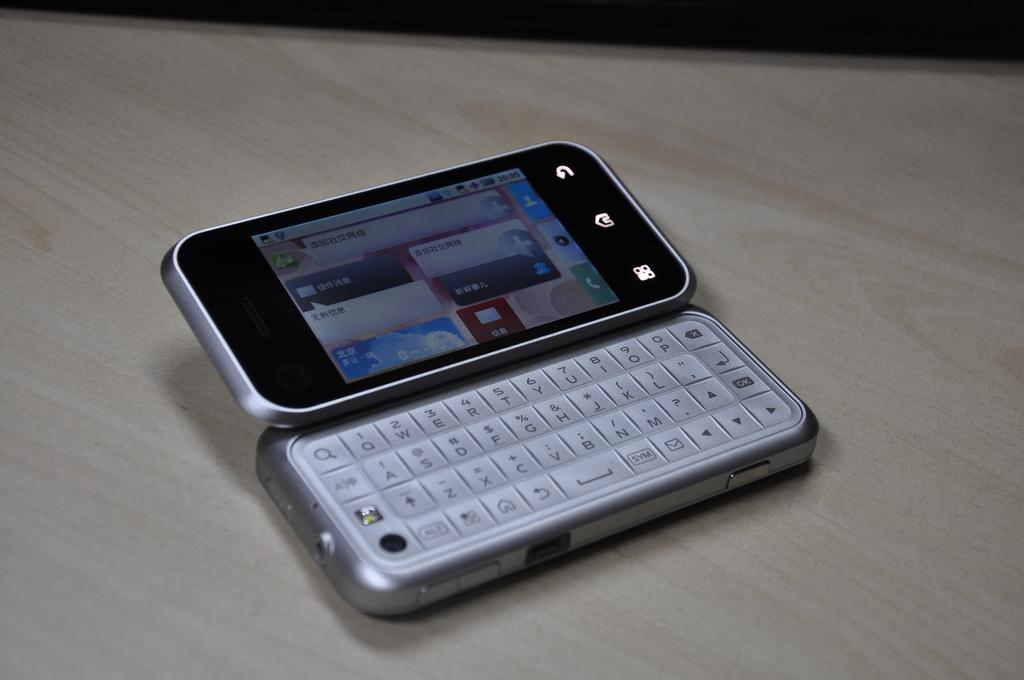<image>
Write a terse but informative summary of the picture. Small cellphone that shows the time at 20:05 